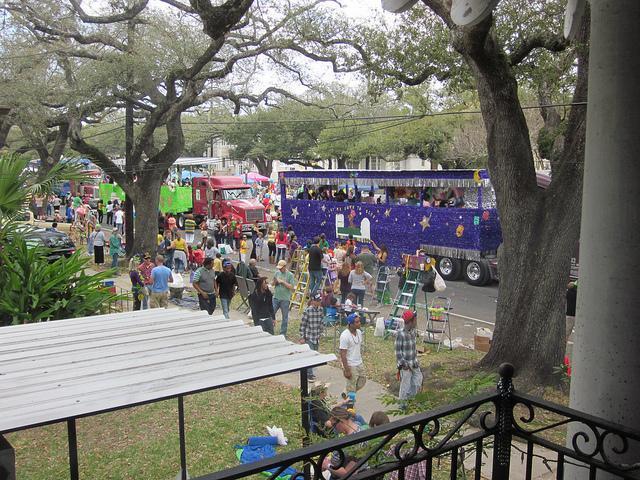How many people can you see?
Give a very brief answer. 3. How many kites have legs?
Give a very brief answer. 0. 